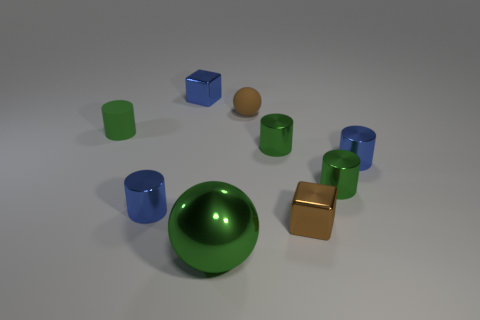Subtract all purple spheres. How many green cylinders are left? 3 Subtract all blue cylinders. How many cylinders are left? 3 Subtract 1 cylinders. How many cylinders are left? 4 Subtract all blue cylinders. How many cylinders are left? 3 Add 1 green metal cylinders. How many objects exist? 10 Subtract all gray cylinders. Subtract all cyan spheres. How many cylinders are left? 5 Subtract 1 brown cubes. How many objects are left? 8 Subtract all cylinders. How many objects are left? 4 Subtract all tiny blue metal cubes. Subtract all small rubber spheres. How many objects are left? 7 Add 7 matte cylinders. How many matte cylinders are left? 8 